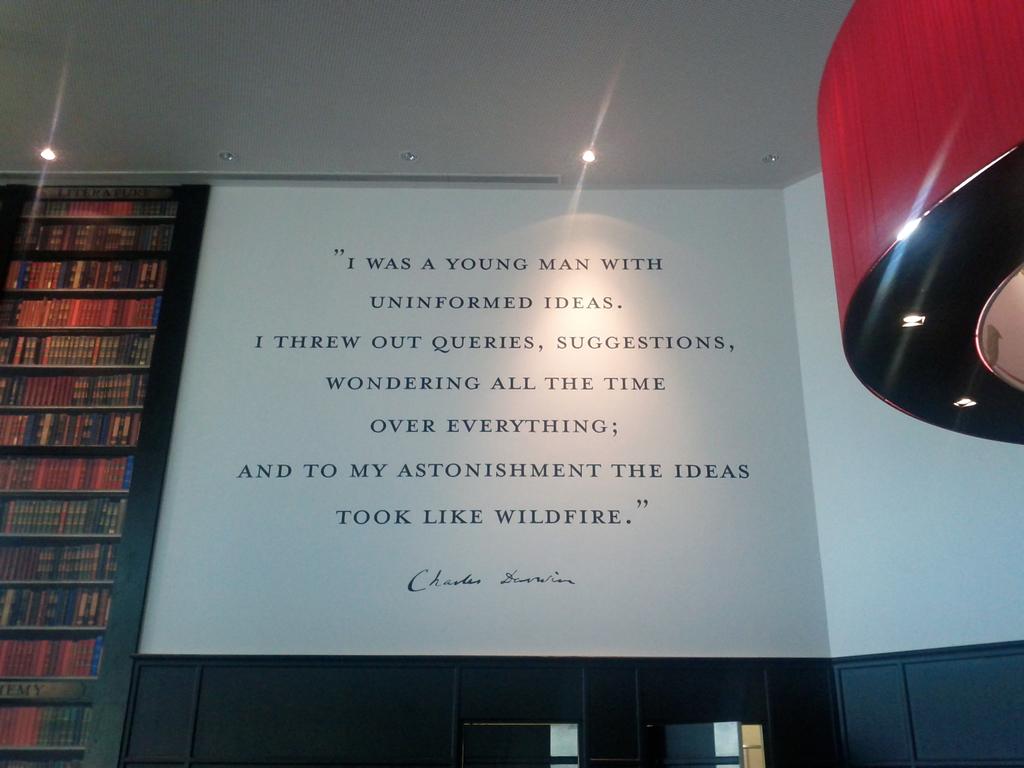What did the ideas take like?
Ensure brevity in your answer.  Wildfire. What is the last word of the quote?
Your answer should be compact. Wildfire. 